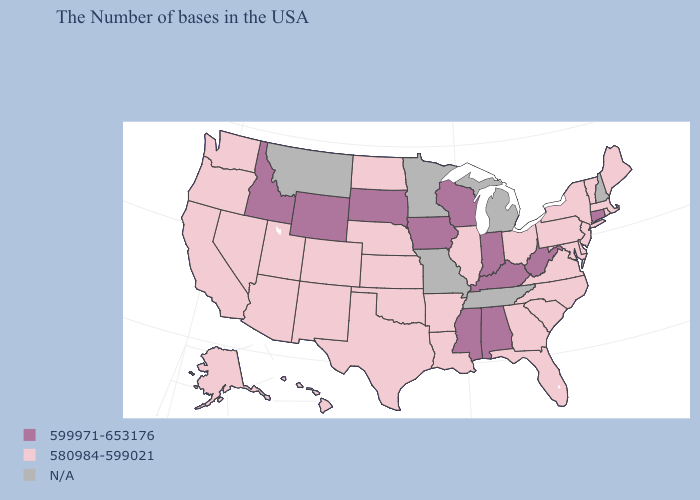Name the states that have a value in the range N/A?
Give a very brief answer. New Hampshire, Michigan, Tennessee, Missouri, Minnesota, Montana. Which states have the lowest value in the USA?
Give a very brief answer. Maine, Massachusetts, Rhode Island, Vermont, New York, New Jersey, Delaware, Maryland, Pennsylvania, Virginia, North Carolina, South Carolina, Ohio, Florida, Georgia, Illinois, Louisiana, Arkansas, Kansas, Nebraska, Oklahoma, Texas, North Dakota, Colorado, New Mexico, Utah, Arizona, Nevada, California, Washington, Oregon, Alaska, Hawaii. Name the states that have a value in the range N/A?
Keep it brief. New Hampshire, Michigan, Tennessee, Missouri, Minnesota, Montana. Name the states that have a value in the range 580984-599021?
Quick response, please. Maine, Massachusetts, Rhode Island, Vermont, New York, New Jersey, Delaware, Maryland, Pennsylvania, Virginia, North Carolina, South Carolina, Ohio, Florida, Georgia, Illinois, Louisiana, Arkansas, Kansas, Nebraska, Oklahoma, Texas, North Dakota, Colorado, New Mexico, Utah, Arizona, Nevada, California, Washington, Oregon, Alaska, Hawaii. Which states hav the highest value in the Northeast?
Answer briefly. Connecticut. What is the value of Tennessee?
Keep it brief. N/A. What is the highest value in the USA?
Quick response, please. 599971-653176. Name the states that have a value in the range 599971-653176?
Concise answer only. Connecticut, West Virginia, Kentucky, Indiana, Alabama, Wisconsin, Mississippi, Iowa, South Dakota, Wyoming, Idaho. What is the lowest value in the USA?
Be succinct. 580984-599021. Among the states that border Alabama , which have the highest value?
Concise answer only. Mississippi. Does North Dakota have the highest value in the USA?
Keep it brief. No. Name the states that have a value in the range 580984-599021?
Be succinct. Maine, Massachusetts, Rhode Island, Vermont, New York, New Jersey, Delaware, Maryland, Pennsylvania, Virginia, North Carolina, South Carolina, Ohio, Florida, Georgia, Illinois, Louisiana, Arkansas, Kansas, Nebraska, Oklahoma, Texas, North Dakota, Colorado, New Mexico, Utah, Arizona, Nevada, California, Washington, Oregon, Alaska, Hawaii. Name the states that have a value in the range N/A?
Keep it brief. New Hampshire, Michigan, Tennessee, Missouri, Minnesota, Montana. Which states have the lowest value in the MidWest?
Keep it brief. Ohio, Illinois, Kansas, Nebraska, North Dakota. Does the first symbol in the legend represent the smallest category?
Short answer required. No. 